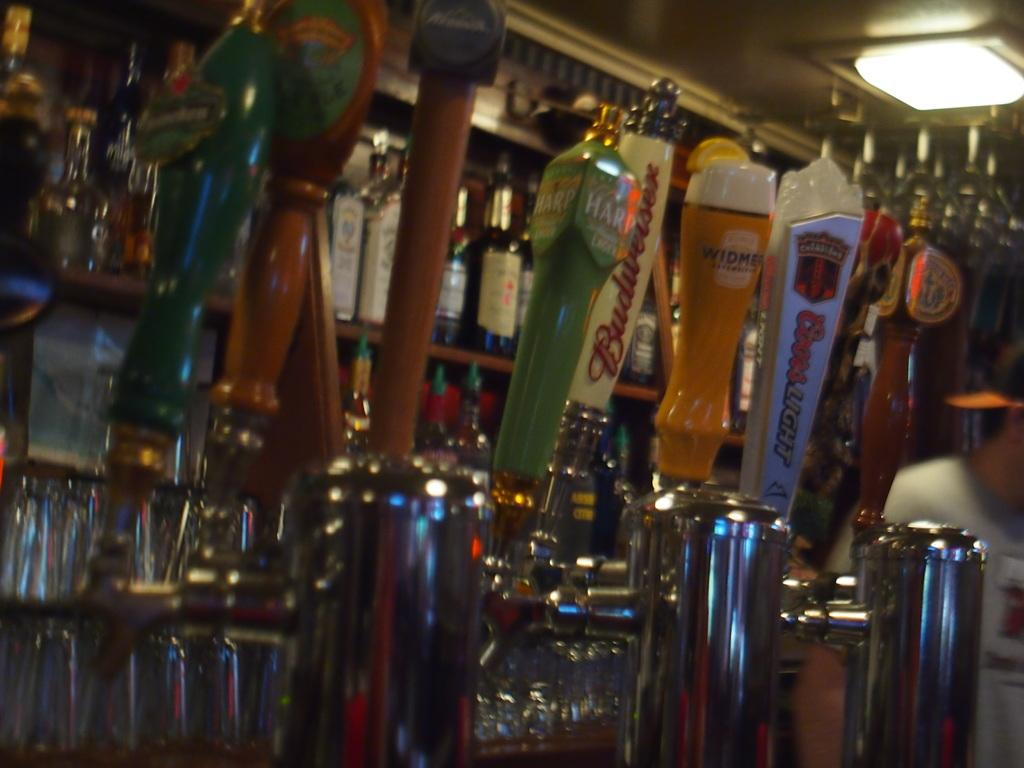<image>
Give a short and clear explanation of the subsequent image. A bar with sevral taps including a coors light one 